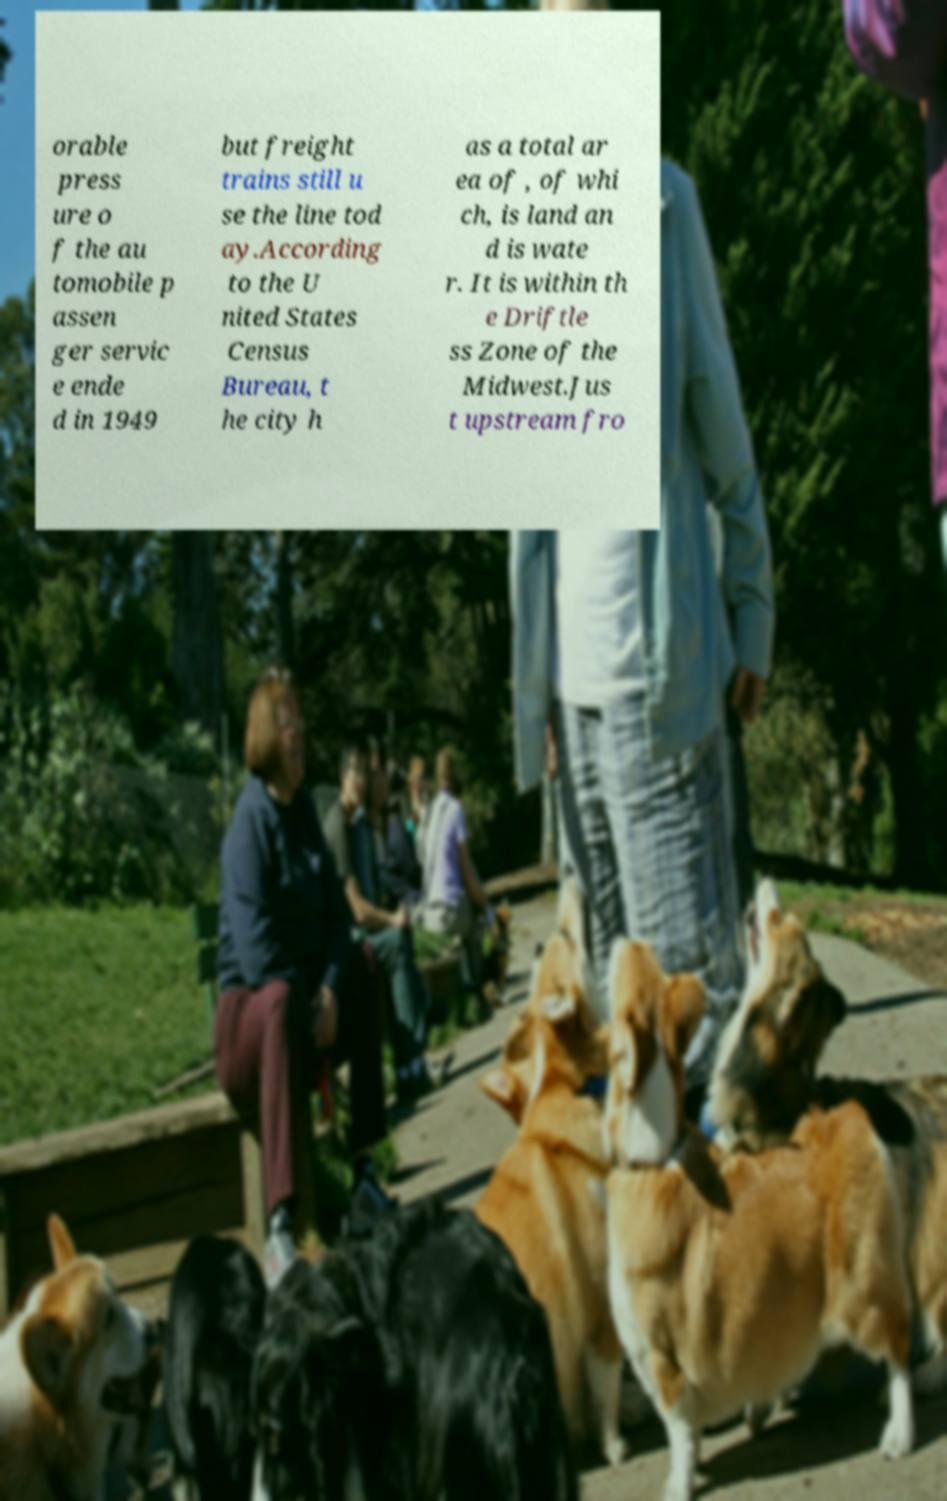What messages or text are displayed in this image? I need them in a readable, typed format. orable press ure o f the au tomobile p assen ger servic e ende d in 1949 but freight trains still u se the line tod ay.According to the U nited States Census Bureau, t he city h as a total ar ea of , of whi ch, is land an d is wate r. It is within th e Driftle ss Zone of the Midwest.Jus t upstream fro 